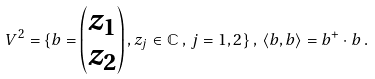Convert formula to latex. <formula><loc_0><loc_0><loc_500><loc_500>V ^ { 2 } = \{ b = \begin{pmatrix} z _ { 1 } \\ z _ { 2 } \end{pmatrix} , z _ { j } \in \mathbb { C } \, , \, j = 1 , 2 \} \, , \, \langle b , b \rangle = b ^ { + } \cdot b \, .</formula> 